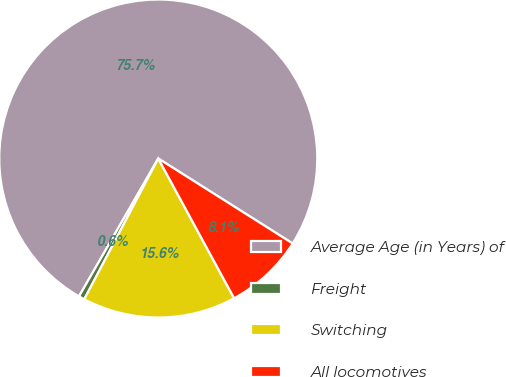Convert chart. <chart><loc_0><loc_0><loc_500><loc_500><pie_chart><fcel>Average Age (in Years) of<fcel>Freight<fcel>Switching<fcel>All locomotives<nl><fcel>75.67%<fcel>0.6%<fcel>15.62%<fcel>8.11%<nl></chart> 